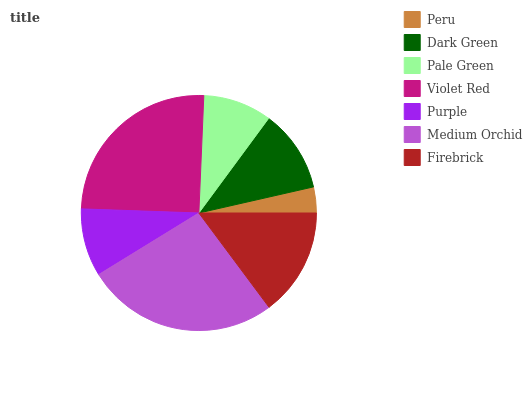Is Peru the minimum?
Answer yes or no. Yes. Is Medium Orchid the maximum?
Answer yes or no. Yes. Is Dark Green the minimum?
Answer yes or no. No. Is Dark Green the maximum?
Answer yes or no. No. Is Dark Green greater than Peru?
Answer yes or no. Yes. Is Peru less than Dark Green?
Answer yes or no. Yes. Is Peru greater than Dark Green?
Answer yes or no. No. Is Dark Green less than Peru?
Answer yes or no. No. Is Dark Green the high median?
Answer yes or no. Yes. Is Dark Green the low median?
Answer yes or no. Yes. Is Peru the high median?
Answer yes or no. No. Is Firebrick the low median?
Answer yes or no. No. 